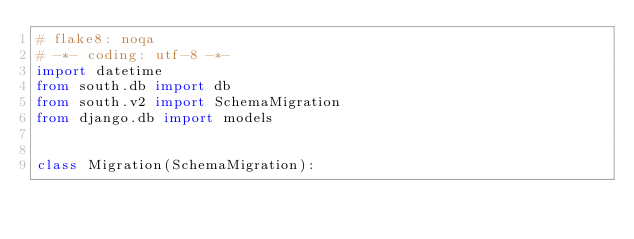<code> <loc_0><loc_0><loc_500><loc_500><_Python_># flake8: noqa
# -*- coding: utf-8 -*-
import datetime
from south.db import db
from south.v2 import SchemaMigration
from django.db import models


class Migration(SchemaMigration):
</code> 